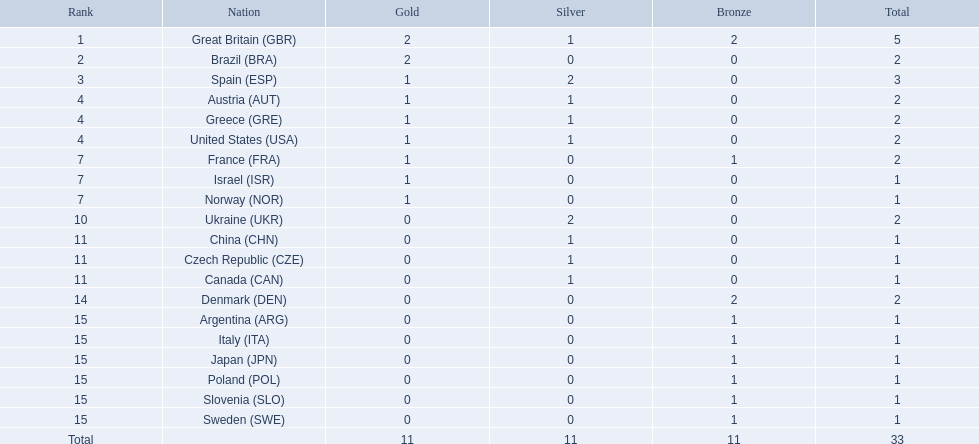What are all of the countries? Great Britain (GBR), Brazil (BRA), Spain (ESP), Austria (AUT), Greece (GRE), United States (USA), France (FRA), Israel (ISR), Norway (NOR), Ukraine (UKR), China (CHN), Czech Republic (CZE), Canada (CAN), Denmark (DEN), Argentina (ARG), Italy (ITA), Japan (JPN), Poland (POL), Slovenia (SLO), Sweden (SWE). Which ones earned a medal? Great Britain (GBR), Brazil (BRA), Spain (ESP), Austria (AUT), Greece (GRE), United States (USA), France (FRA), Israel (ISR), Norway (NOR), Ukraine (UKR), China (CHN), Czech Republic (CZE), Canada (CAN), Denmark (DEN), Argentina (ARG), Italy (ITA), Japan (JPN), Poland (POL), Slovenia (SLO), Sweden (SWE). Which countries earned at least 3 medals? Great Britain (GBR), Spain (ESP). Which country earned 3 medals? Spain (ESP). 